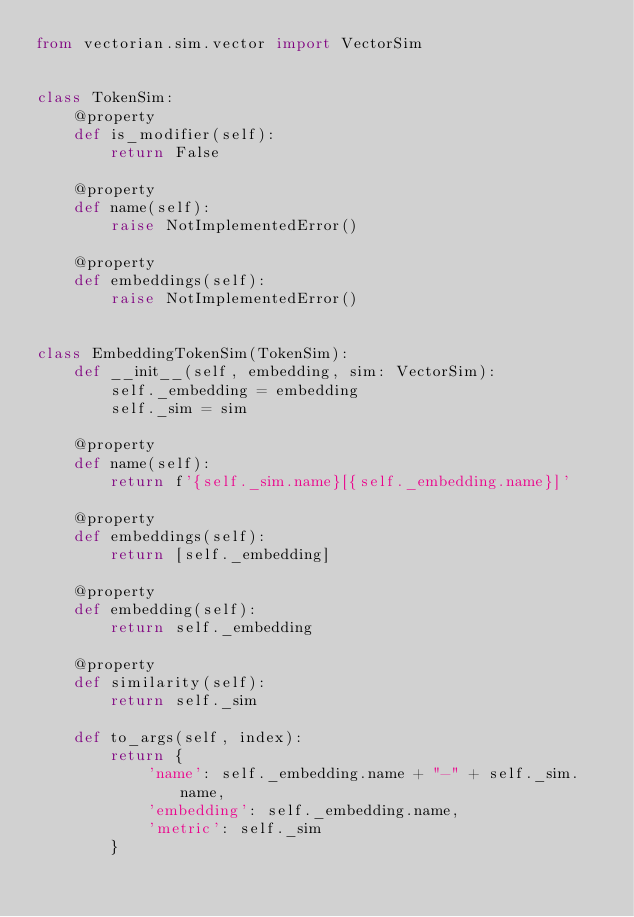Convert code to text. <code><loc_0><loc_0><loc_500><loc_500><_Python_>from vectorian.sim.vector import VectorSim


class TokenSim:
	@property
	def is_modifier(self):
		return False

	@property
	def name(self):
		raise NotImplementedError()

	@property
	def embeddings(self):
		raise NotImplementedError()


class EmbeddingTokenSim(TokenSim):
	def __init__(self, embedding, sim: VectorSim):
		self._embedding = embedding
		self._sim = sim

	@property
	def name(self):
		return f'{self._sim.name}[{self._embedding.name}]'

	@property
	def embeddings(self):
		return [self._embedding]

	@property
	def embedding(self):
		return self._embedding

	@property
	def similarity(self):
		return self._sim

	def to_args(self, index):
		return {
			'name': self._embedding.name + "-" + self._sim.name,
			'embedding': self._embedding.name,
			'metric': self._sim
		}
</code> 